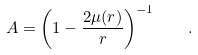<formula> <loc_0><loc_0><loc_500><loc_500>A = \left ( 1 - \frac { 2 \mu ( r ) } r \right ) ^ { - 1 } \quad .</formula> 